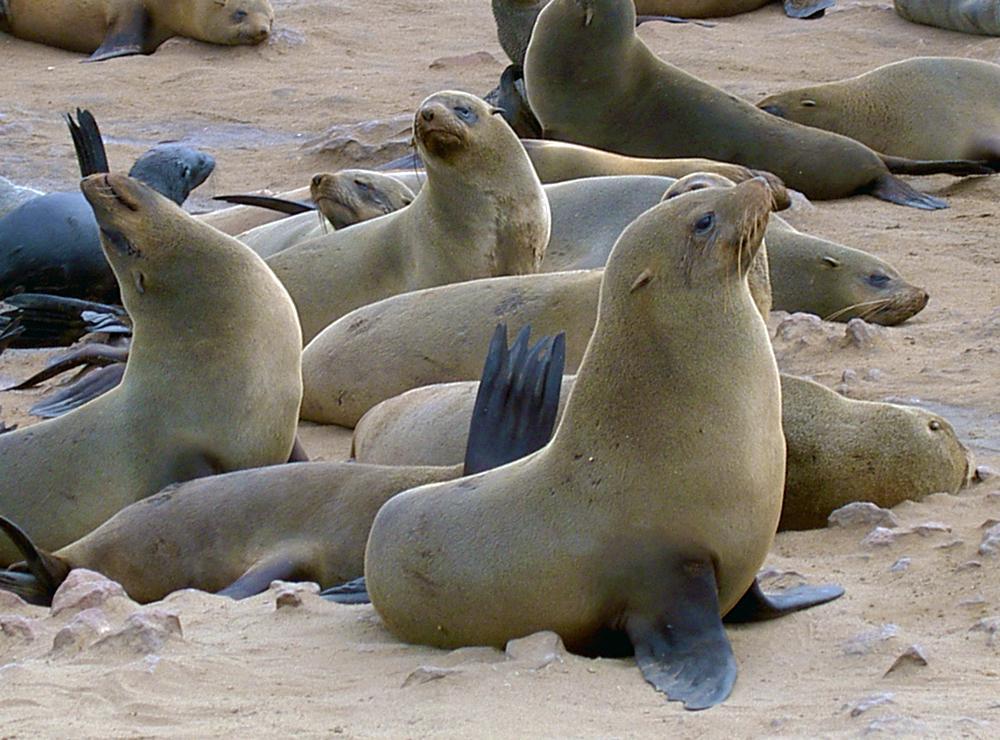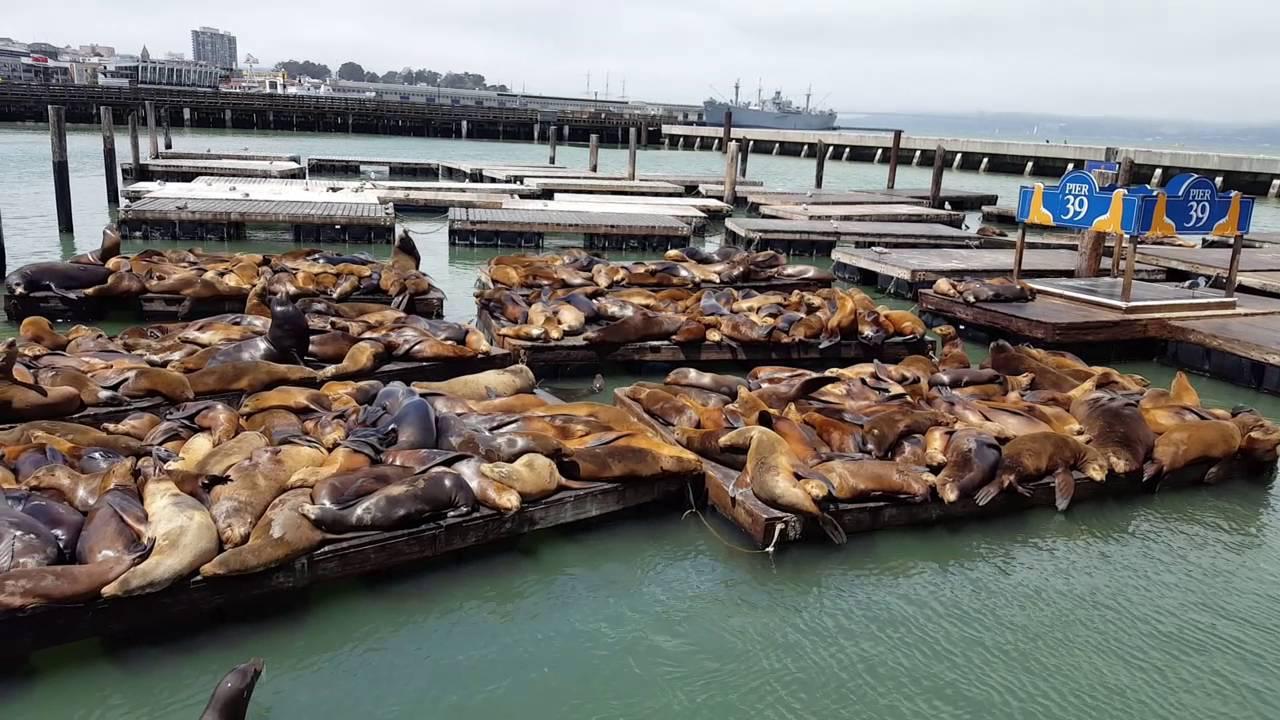The first image is the image on the left, the second image is the image on the right. Considering the images on both sides, is "Waves are coming onto the beach." valid? Answer yes or no. No. The first image is the image on the left, the second image is the image on the right. For the images displayed, is the sentence "Each image shows a mass of at least 15 seals on a natural elevated surface with water visible next to it." factually correct? Answer yes or no. No. 